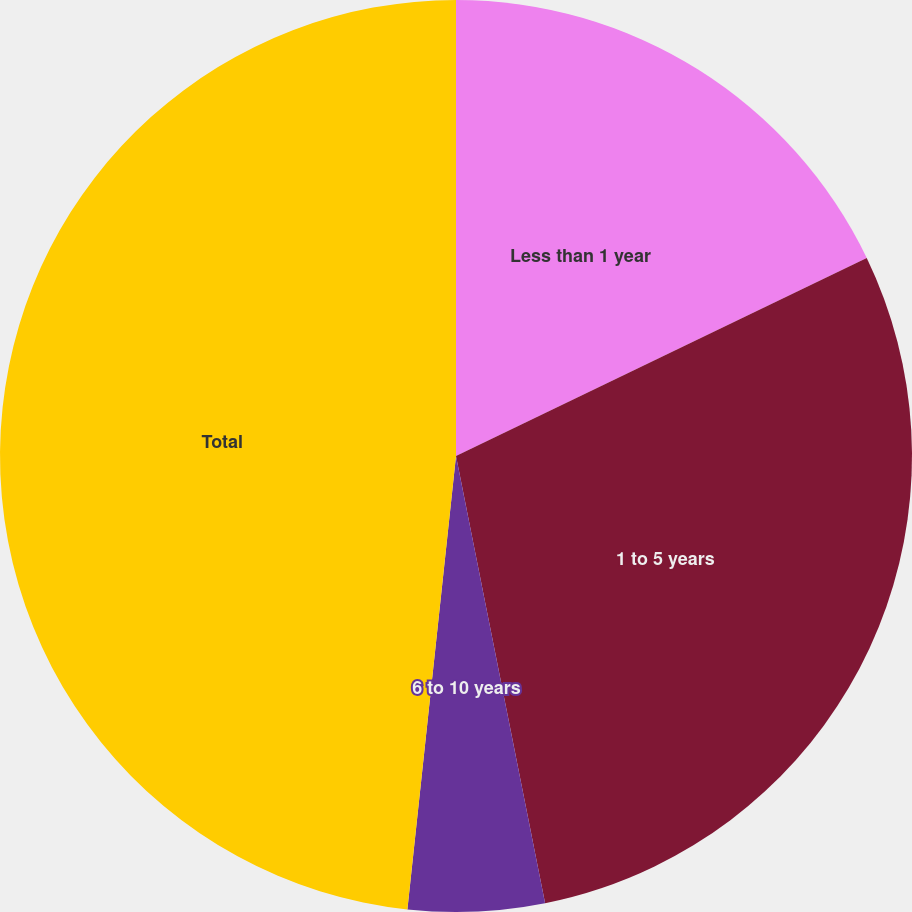Convert chart to OTSL. <chart><loc_0><loc_0><loc_500><loc_500><pie_chart><fcel>Less than 1 year<fcel>1 to 5 years<fcel>6 to 10 years<fcel>Thereafter<fcel>Total<nl><fcel>17.85%<fcel>29.02%<fcel>4.83%<fcel>0.0%<fcel>48.3%<nl></chart> 